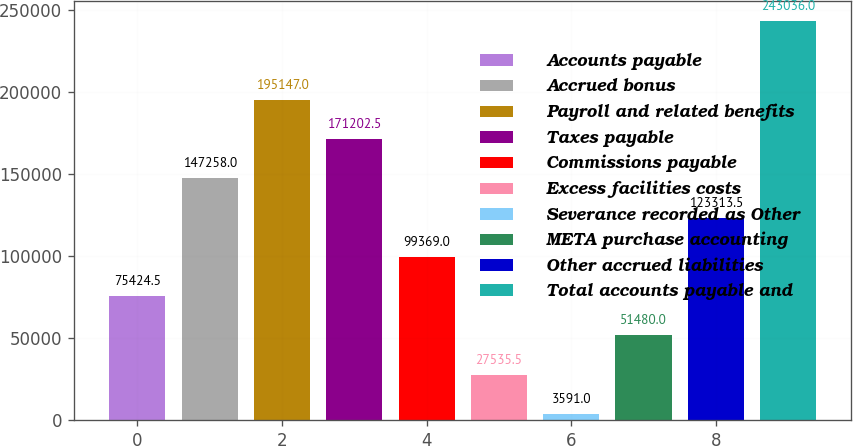<chart> <loc_0><loc_0><loc_500><loc_500><bar_chart><fcel>Accounts payable<fcel>Accrued bonus<fcel>Payroll and related benefits<fcel>Taxes payable<fcel>Commissions payable<fcel>Excess facilities costs<fcel>Severance recorded as Other<fcel>META purchase accounting<fcel>Other accrued liabilities<fcel>Total accounts payable and<nl><fcel>75424.5<fcel>147258<fcel>195147<fcel>171202<fcel>99369<fcel>27535.5<fcel>3591<fcel>51480<fcel>123314<fcel>243036<nl></chart> 